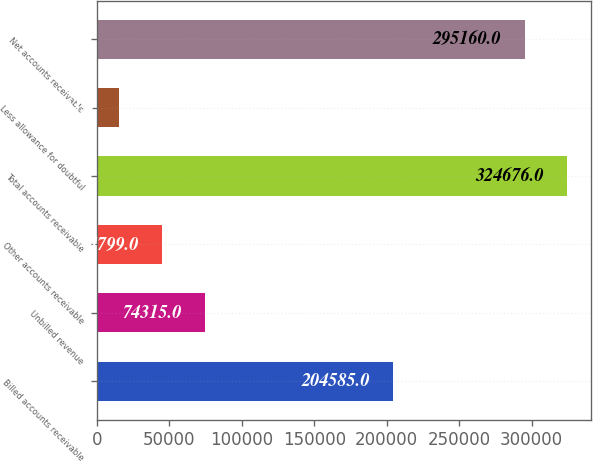Convert chart. <chart><loc_0><loc_0><loc_500><loc_500><bar_chart><fcel>Billed accounts receivable<fcel>Unbilled revenue<fcel>Other accounts receivable<fcel>Total accounts receivable<fcel>Less allowance for doubtful<fcel>Net accounts receivable<nl><fcel>204585<fcel>74315<fcel>44799<fcel>324676<fcel>15283<fcel>295160<nl></chart> 